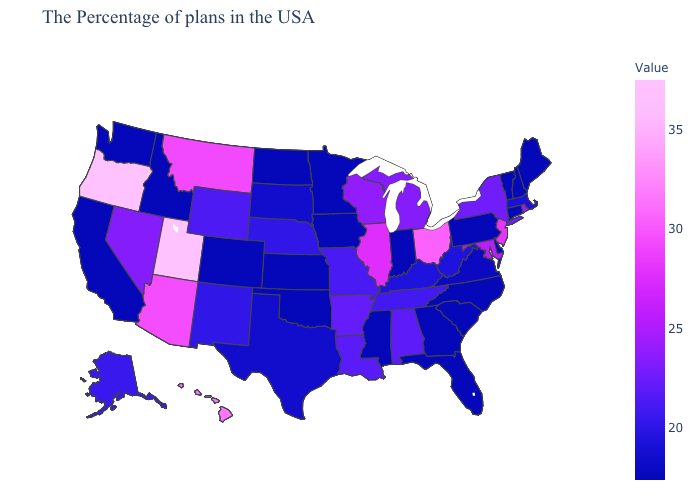Among the states that border Arizona , which have the highest value?
Answer briefly. Utah. Which states have the highest value in the USA?
Give a very brief answer. Utah. Does Maryland have the highest value in the South?
Quick response, please. Yes. Does Iowa have the lowest value in the MidWest?
Short answer required. Yes. 